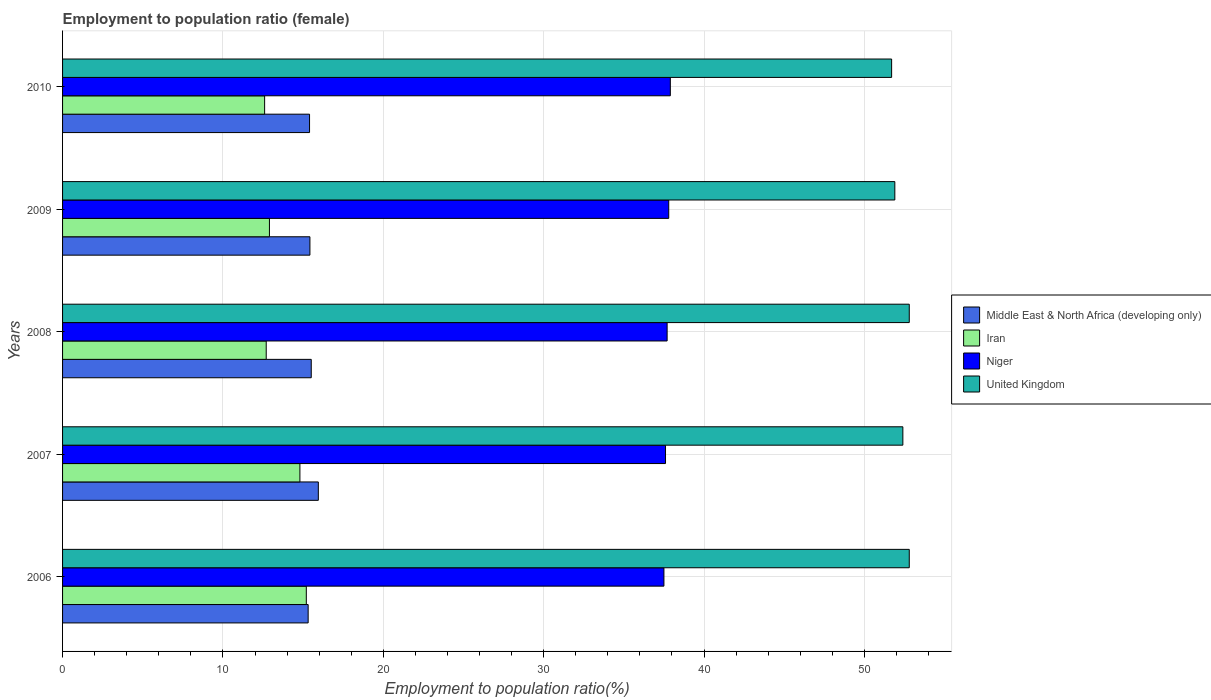How many different coloured bars are there?
Keep it short and to the point. 4. Are the number of bars per tick equal to the number of legend labels?
Provide a short and direct response. Yes. How many bars are there on the 3rd tick from the top?
Your answer should be very brief. 4. What is the label of the 2nd group of bars from the top?
Offer a terse response. 2009. In how many cases, is the number of bars for a given year not equal to the number of legend labels?
Ensure brevity in your answer.  0. What is the employment to population ratio in United Kingdom in 2009?
Make the answer very short. 51.9. Across all years, what is the maximum employment to population ratio in Iran?
Make the answer very short. 15.2. Across all years, what is the minimum employment to population ratio in United Kingdom?
Provide a succinct answer. 51.7. In which year was the employment to population ratio in United Kingdom maximum?
Keep it short and to the point. 2006. What is the total employment to population ratio in Iran in the graph?
Offer a very short reply. 68.2. What is the difference between the employment to population ratio in Niger in 2007 and that in 2009?
Your answer should be compact. -0.2. What is the average employment to population ratio in Iran per year?
Ensure brevity in your answer.  13.64. In the year 2006, what is the difference between the employment to population ratio in United Kingdom and employment to population ratio in Niger?
Provide a short and direct response. 15.3. In how many years, is the employment to population ratio in Iran greater than 18 %?
Keep it short and to the point. 0. What is the ratio of the employment to population ratio in Niger in 2006 to that in 2009?
Ensure brevity in your answer.  0.99. Is the employment to population ratio in Niger in 2006 less than that in 2007?
Provide a succinct answer. Yes. Is the difference between the employment to population ratio in United Kingdom in 2009 and 2010 greater than the difference between the employment to population ratio in Niger in 2009 and 2010?
Keep it short and to the point. Yes. What is the difference between the highest and the second highest employment to population ratio in Iran?
Your answer should be compact. 0.4. What is the difference between the highest and the lowest employment to population ratio in Niger?
Your response must be concise. 0.4. In how many years, is the employment to population ratio in Iran greater than the average employment to population ratio in Iran taken over all years?
Your answer should be compact. 2. Is the sum of the employment to population ratio in Iran in 2008 and 2009 greater than the maximum employment to population ratio in United Kingdom across all years?
Your response must be concise. No. What does the 1st bar from the top in 2007 represents?
Offer a very short reply. United Kingdom. What does the 1st bar from the bottom in 2009 represents?
Make the answer very short. Middle East & North Africa (developing only). Is it the case that in every year, the sum of the employment to population ratio in Middle East & North Africa (developing only) and employment to population ratio in Niger is greater than the employment to population ratio in United Kingdom?
Offer a terse response. Yes. How many bars are there?
Your answer should be compact. 20. Does the graph contain any zero values?
Your answer should be compact. No. Where does the legend appear in the graph?
Your response must be concise. Center right. How are the legend labels stacked?
Give a very brief answer. Vertical. What is the title of the graph?
Provide a succinct answer. Employment to population ratio (female). Does "Panama" appear as one of the legend labels in the graph?
Your response must be concise. No. What is the label or title of the X-axis?
Your answer should be very brief. Employment to population ratio(%). What is the label or title of the Y-axis?
Give a very brief answer. Years. What is the Employment to population ratio(%) of Middle East & North Africa (developing only) in 2006?
Provide a short and direct response. 15.31. What is the Employment to population ratio(%) of Iran in 2006?
Offer a very short reply. 15.2. What is the Employment to population ratio(%) of Niger in 2006?
Offer a terse response. 37.5. What is the Employment to population ratio(%) in United Kingdom in 2006?
Make the answer very short. 52.8. What is the Employment to population ratio(%) of Middle East & North Africa (developing only) in 2007?
Offer a terse response. 15.95. What is the Employment to population ratio(%) of Iran in 2007?
Your answer should be compact. 14.8. What is the Employment to population ratio(%) in Niger in 2007?
Keep it short and to the point. 37.6. What is the Employment to population ratio(%) of United Kingdom in 2007?
Keep it short and to the point. 52.4. What is the Employment to population ratio(%) of Middle East & North Africa (developing only) in 2008?
Your response must be concise. 15.51. What is the Employment to population ratio(%) in Iran in 2008?
Give a very brief answer. 12.7. What is the Employment to population ratio(%) of Niger in 2008?
Your response must be concise. 37.7. What is the Employment to population ratio(%) in United Kingdom in 2008?
Offer a terse response. 52.8. What is the Employment to population ratio(%) in Middle East & North Africa (developing only) in 2009?
Offer a very short reply. 15.42. What is the Employment to population ratio(%) in Iran in 2009?
Your answer should be very brief. 12.9. What is the Employment to population ratio(%) of Niger in 2009?
Give a very brief answer. 37.8. What is the Employment to population ratio(%) in United Kingdom in 2009?
Your answer should be very brief. 51.9. What is the Employment to population ratio(%) of Middle East & North Africa (developing only) in 2010?
Give a very brief answer. 15.4. What is the Employment to population ratio(%) of Iran in 2010?
Your response must be concise. 12.6. What is the Employment to population ratio(%) of Niger in 2010?
Your answer should be compact. 37.9. What is the Employment to population ratio(%) of United Kingdom in 2010?
Offer a very short reply. 51.7. Across all years, what is the maximum Employment to population ratio(%) in Middle East & North Africa (developing only)?
Offer a terse response. 15.95. Across all years, what is the maximum Employment to population ratio(%) of Iran?
Your answer should be very brief. 15.2. Across all years, what is the maximum Employment to population ratio(%) in Niger?
Ensure brevity in your answer.  37.9. Across all years, what is the maximum Employment to population ratio(%) in United Kingdom?
Ensure brevity in your answer.  52.8. Across all years, what is the minimum Employment to population ratio(%) in Middle East & North Africa (developing only)?
Give a very brief answer. 15.31. Across all years, what is the minimum Employment to population ratio(%) of Iran?
Make the answer very short. 12.6. Across all years, what is the minimum Employment to population ratio(%) of Niger?
Offer a terse response. 37.5. Across all years, what is the minimum Employment to population ratio(%) of United Kingdom?
Provide a succinct answer. 51.7. What is the total Employment to population ratio(%) in Middle East & North Africa (developing only) in the graph?
Your response must be concise. 77.6. What is the total Employment to population ratio(%) of Iran in the graph?
Offer a very short reply. 68.2. What is the total Employment to population ratio(%) in Niger in the graph?
Provide a short and direct response. 188.5. What is the total Employment to population ratio(%) in United Kingdom in the graph?
Your response must be concise. 261.6. What is the difference between the Employment to population ratio(%) of Middle East & North Africa (developing only) in 2006 and that in 2007?
Ensure brevity in your answer.  -0.64. What is the difference between the Employment to population ratio(%) in Iran in 2006 and that in 2007?
Provide a succinct answer. 0.4. What is the difference between the Employment to population ratio(%) in Middle East & North Africa (developing only) in 2006 and that in 2008?
Provide a succinct answer. -0.19. What is the difference between the Employment to population ratio(%) in Iran in 2006 and that in 2008?
Give a very brief answer. 2.5. What is the difference between the Employment to population ratio(%) of Middle East & North Africa (developing only) in 2006 and that in 2009?
Your answer should be compact. -0.11. What is the difference between the Employment to population ratio(%) of Middle East & North Africa (developing only) in 2006 and that in 2010?
Your response must be concise. -0.09. What is the difference between the Employment to population ratio(%) in Iran in 2006 and that in 2010?
Your answer should be compact. 2.6. What is the difference between the Employment to population ratio(%) of Niger in 2006 and that in 2010?
Your response must be concise. -0.4. What is the difference between the Employment to population ratio(%) in Middle East & North Africa (developing only) in 2007 and that in 2008?
Provide a succinct answer. 0.44. What is the difference between the Employment to population ratio(%) of Iran in 2007 and that in 2008?
Your answer should be very brief. 2.1. What is the difference between the Employment to population ratio(%) of United Kingdom in 2007 and that in 2008?
Offer a very short reply. -0.4. What is the difference between the Employment to population ratio(%) in Middle East & North Africa (developing only) in 2007 and that in 2009?
Provide a short and direct response. 0.52. What is the difference between the Employment to population ratio(%) in Middle East & North Africa (developing only) in 2007 and that in 2010?
Your answer should be compact. 0.55. What is the difference between the Employment to population ratio(%) in Iran in 2007 and that in 2010?
Provide a short and direct response. 2.2. What is the difference between the Employment to population ratio(%) of Middle East & North Africa (developing only) in 2008 and that in 2009?
Keep it short and to the point. 0.08. What is the difference between the Employment to population ratio(%) of Iran in 2008 and that in 2009?
Make the answer very short. -0.2. What is the difference between the Employment to population ratio(%) of United Kingdom in 2008 and that in 2009?
Your response must be concise. 0.9. What is the difference between the Employment to population ratio(%) of Middle East & North Africa (developing only) in 2008 and that in 2010?
Your answer should be very brief. 0.11. What is the difference between the Employment to population ratio(%) in Iran in 2008 and that in 2010?
Provide a succinct answer. 0.1. What is the difference between the Employment to population ratio(%) in Niger in 2008 and that in 2010?
Your response must be concise. -0.2. What is the difference between the Employment to population ratio(%) of Middle East & North Africa (developing only) in 2009 and that in 2010?
Give a very brief answer. 0.02. What is the difference between the Employment to population ratio(%) in Iran in 2009 and that in 2010?
Ensure brevity in your answer.  0.3. What is the difference between the Employment to population ratio(%) of Niger in 2009 and that in 2010?
Your answer should be very brief. -0.1. What is the difference between the Employment to population ratio(%) in United Kingdom in 2009 and that in 2010?
Your response must be concise. 0.2. What is the difference between the Employment to population ratio(%) of Middle East & North Africa (developing only) in 2006 and the Employment to population ratio(%) of Iran in 2007?
Your response must be concise. 0.51. What is the difference between the Employment to population ratio(%) of Middle East & North Africa (developing only) in 2006 and the Employment to population ratio(%) of Niger in 2007?
Keep it short and to the point. -22.29. What is the difference between the Employment to population ratio(%) of Middle East & North Africa (developing only) in 2006 and the Employment to population ratio(%) of United Kingdom in 2007?
Offer a terse response. -37.09. What is the difference between the Employment to population ratio(%) of Iran in 2006 and the Employment to population ratio(%) of Niger in 2007?
Offer a very short reply. -22.4. What is the difference between the Employment to population ratio(%) of Iran in 2006 and the Employment to population ratio(%) of United Kingdom in 2007?
Provide a succinct answer. -37.2. What is the difference between the Employment to population ratio(%) in Niger in 2006 and the Employment to population ratio(%) in United Kingdom in 2007?
Give a very brief answer. -14.9. What is the difference between the Employment to population ratio(%) in Middle East & North Africa (developing only) in 2006 and the Employment to population ratio(%) in Iran in 2008?
Offer a very short reply. 2.61. What is the difference between the Employment to population ratio(%) of Middle East & North Africa (developing only) in 2006 and the Employment to population ratio(%) of Niger in 2008?
Ensure brevity in your answer.  -22.39. What is the difference between the Employment to population ratio(%) in Middle East & North Africa (developing only) in 2006 and the Employment to population ratio(%) in United Kingdom in 2008?
Offer a terse response. -37.49. What is the difference between the Employment to population ratio(%) of Iran in 2006 and the Employment to population ratio(%) of Niger in 2008?
Make the answer very short. -22.5. What is the difference between the Employment to population ratio(%) of Iran in 2006 and the Employment to population ratio(%) of United Kingdom in 2008?
Your answer should be very brief. -37.6. What is the difference between the Employment to population ratio(%) of Niger in 2006 and the Employment to population ratio(%) of United Kingdom in 2008?
Your answer should be very brief. -15.3. What is the difference between the Employment to population ratio(%) in Middle East & North Africa (developing only) in 2006 and the Employment to population ratio(%) in Iran in 2009?
Give a very brief answer. 2.41. What is the difference between the Employment to population ratio(%) in Middle East & North Africa (developing only) in 2006 and the Employment to population ratio(%) in Niger in 2009?
Your answer should be compact. -22.49. What is the difference between the Employment to population ratio(%) in Middle East & North Africa (developing only) in 2006 and the Employment to population ratio(%) in United Kingdom in 2009?
Offer a very short reply. -36.59. What is the difference between the Employment to population ratio(%) of Iran in 2006 and the Employment to population ratio(%) of Niger in 2009?
Offer a terse response. -22.6. What is the difference between the Employment to population ratio(%) in Iran in 2006 and the Employment to population ratio(%) in United Kingdom in 2009?
Your response must be concise. -36.7. What is the difference between the Employment to population ratio(%) in Niger in 2006 and the Employment to population ratio(%) in United Kingdom in 2009?
Provide a succinct answer. -14.4. What is the difference between the Employment to population ratio(%) in Middle East & North Africa (developing only) in 2006 and the Employment to population ratio(%) in Iran in 2010?
Give a very brief answer. 2.71. What is the difference between the Employment to population ratio(%) of Middle East & North Africa (developing only) in 2006 and the Employment to population ratio(%) of Niger in 2010?
Provide a short and direct response. -22.59. What is the difference between the Employment to population ratio(%) of Middle East & North Africa (developing only) in 2006 and the Employment to population ratio(%) of United Kingdom in 2010?
Ensure brevity in your answer.  -36.39. What is the difference between the Employment to population ratio(%) of Iran in 2006 and the Employment to population ratio(%) of Niger in 2010?
Offer a very short reply. -22.7. What is the difference between the Employment to population ratio(%) in Iran in 2006 and the Employment to population ratio(%) in United Kingdom in 2010?
Make the answer very short. -36.5. What is the difference between the Employment to population ratio(%) of Niger in 2006 and the Employment to population ratio(%) of United Kingdom in 2010?
Ensure brevity in your answer.  -14.2. What is the difference between the Employment to population ratio(%) of Middle East & North Africa (developing only) in 2007 and the Employment to population ratio(%) of Iran in 2008?
Give a very brief answer. 3.25. What is the difference between the Employment to population ratio(%) of Middle East & North Africa (developing only) in 2007 and the Employment to population ratio(%) of Niger in 2008?
Ensure brevity in your answer.  -21.75. What is the difference between the Employment to population ratio(%) of Middle East & North Africa (developing only) in 2007 and the Employment to population ratio(%) of United Kingdom in 2008?
Your response must be concise. -36.85. What is the difference between the Employment to population ratio(%) of Iran in 2007 and the Employment to population ratio(%) of Niger in 2008?
Your answer should be compact. -22.9. What is the difference between the Employment to population ratio(%) of Iran in 2007 and the Employment to population ratio(%) of United Kingdom in 2008?
Provide a short and direct response. -38. What is the difference between the Employment to population ratio(%) in Niger in 2007 and the Employment to population ratio(%) in United Kingdom in 2008?
Offer a very short reply. -15.2. What is the difference between the Employment to population ratio(%) in Middle East & North Africa (developing only) in 2007 and the Employment to population ratio(%) in Iran in 2009?
Your response must be concise. 3.05. What is the difference between the Employment to population ratio(%) of Middle East & North Africa (developing only) in 2007 and the Employment to population ratio(%) of Niger in 2009?
Offer a terse response. -21.85. What is the difference between the Employment to population ratio(%) of Middle East & North Africa (developing only) in 2007 and the Employment to population ratio(%) of United Kingdom in 2009?
Give a very brief answer. -35.95. What is the difference between the Employment to population ratio(%) of Iran in 2007 and the Employment to population ratio(%) of Niger in 2009?
Keep it short and to the point. -23. What is the difference between the Employment to population ratio(%) of Iran in 2007 and the Employment to population ratio(%) of United Kingdom in 2009?
Offer a very short reply. -37.1. What is the difference between the Employment to population ratio(%) in Niger in 2007 and the Employment to population ratio(%) in United Kingdom in 2009?
Offer a terse response. -14.3. What is the difference between the Employment to population ratio(%) of Middle East & North Africa (developing only) in 2007 and the Employment to population ratio(%) of Iran in 2010?
Make the answer very short. 3.35. What is the difference between the Employment to population ratio(%) in Middle East & North Africa (developing only) in 2007 and the Employment to population ratio(%) in Niger in 2010?
Your response must be concise. -21.95. What is the difference between the Employment to population ratio(%) of Middle East & North Africa (developing only) in 2007 and the Employment to population ratio(%) of United Kingdom in 2010?
Make the answer very short. -35.75. What is the difference between the Employment to population ratio(%) of Iran in 2007 and the Employment to population ratio(%) of Niger in 2010?
Your answer should be compact. -23.1. What is the difference between the Employment to population ratio(%) of Iran in 2007 and the Employment to population ratio(%) of United Kingdom in 2010?
Ensure brevity in your answer.  -36.9. What is the difference between the Employment to population ratio(%) of Niger in 2007 and the Employment to population ratio(%) of United Kingdom in 2010?
Your answer should be very brief. -14.1. What is the difference between the Employment to population ratio(%) in Middle East & North Africa (developing only) in 2008 and the Employment to population ratio(%) in Iran in 2009?
Keep it short and to the point. 2.61. What is the difference between the Employment to population ratio(%) of Middle East & North Africa (developing only) in 2008 and the Employment to population ratio(%) of Niger in 2009?
Provide a short and direct response. -22.29. What is the difference between the Employment to population ratio(%) of Middle East & North Africa (developing only) in 2008 and the Employment to population ratio(%) of United Kingdom in 2009?
Give a very brief answer. -36.39. What is the difference between the Employment to population ratio(%) in Iran in 2008 and the Employment to population ratio(%) in Niger in 2009?
Offer a terse response. -25.1. What is the difference between the Employment to population ratio(%) in Iran in 2008 and the Employment to population ratio(%) in United Kingdom in 2009?
Your response must be concise. -39.2. What is the difference between the Employment to population ratio(%) of Niger in 2008 and the Employment to population ratio(%) of United Kingdom in 2009?
Offer a terse response. -14.2. What is the difference between the Employment to population ratio(%) of Middle East & North Africa (developing only) in 2008 and the Employment to population ratio(%) of Iran in 2010?
Give a very brief answer. 2.91. What is the difference between the Employment to population ratio(%) in Middle East & North Africa (developing only) in 2008 and the Employment to population ratio(%) in Niger in 2010?
Keep it short and to the point. -22.39. What is the difference between the Employment to population ratio(%) in Middle East & North Africa (developing only) in 2008 and the Employment to population ratio(%) in United Kingdom in 2010?
Your answer should be compact. -36.19. What is the difference between the Employment to population ratio(%) of Iran in 2008 and the Employment to population ratio(%) of Niger in 2010?
Keep it short and to the point. -25.2. What is the difference between the Employment to population ratio(%) in Iran in 2008 and the Employment to population ratio(%) in United Kingdom in 2010?
Make the answer very short. -39. What is the difference between the Employment to population ratio(%) in Middle East & North Africa (developing only) in 2009 and the Employment to population ratio(%) in Iran in 2010?
Your answer should be very brief. 2.82. What is the difference between the Employment to population ratio(%) in Middle East & North Africa (developing only) in 2009 and the Employment to population ratio(%) in Niger in 2010?
Give a very brief answer. -22.48. What is the difference between the Employment to population ratio(%) in Middle East & North Africa (developing only) in 2009 and the Employment to population ratio(%) in United Kingdom in 2010?
Give a very brief answer. -36.28. What is the difference between the Employment to population ratio(%) of Iran in 2009 and the Employment to population ratio(%) of United Kingdom in 2010?
Provide a short and direct response. -38.8. What is the difference between the Employment to population ratio(%) in Niger in 2009 and the Employment to population ratio(%) in United Kingdom in 2010?
Your answer should be compact. -13.9. What is the average Employment to population ratio(%) in Middle East & North Africa (developing only) per year?
Offer a terse response. 15.52. What is the average Employment to population ratio(%) of Iran per year?
Give a very brief answer. 13.64. What is the average Employment to population ratio(%) of Niger per year?
Provide a short and direct response. 37.7. What is the average Employment to population ratio(%) in United Kingdom per year?
Offer a terse response. 52.32. In the year 2006, what is the difference between the Employment to population ratio(%) in Middle East & North Africa (developing only) and Employment to population ratio(%) in Iran?
Your answer should be compact. 0.11. In the year 2006, what is the difference between the Employment to population ratio(%) in Middle East & North Africa (developing only) and Employment to population ratio(%) in Niger?
Your answer should be very brief. -22.19. In the year 2006, what is the difference between the Employment to population ratio(%) in Middle East & North Africa (developing only) and Employment to population ratio(%) in United Kingdom?
Keep it short and to the point. -37.49. In the year 2006, what is the difference between the Employment to population ratio(%) in Iran and Employment to population ratio(%) in Niger?
Make the answer very short. -22.3. In the year 2006, what is the difference between the Employment to population ratio(%) of Iran and Employment to population ratio(%) of United Kingdom?
Offer a very short reply. -37.6. In the year 2006, what is the difference between the Employment to population ratio(%) in Niger and Employment to population ratio(%) in United Kingdom?
Make the answer very short. -15.3. In the year 2007, what is the difference between the Employment to population ratio(%) of Middle East & North Africa (developing only) and Employment to population ratio(%) of Iran?
Give a very brief answer. 1.15. In the year 2007, what is the difference between the Employment to population ratio(%) of Middle East & North Africa (developing only) and Employment to population ratio(%) of Niger?
Provide a succinct answer. -21.65. In the year 2007, what is the difference between the Employment to population ratio(%) of Middle East & North Africa (developing only) and Employment to population ratio(%) of United Kingdom?
Your answer should be compact. -36.45. In the year 2007, what is the difference between the Employment to population ratio(%) in Iran and Employment to population ratio(%) in Niger?
Ensure brevity in your answer.  -22.8. In the year 2007, what is the difference between the Employment to population ratio(%) in Iran and Employment to population ratio(%) in United Kingdom?
Provide a short and direct response. -37.6. In the year 2007, what is the difference between the Employment to population ratio(%) in Niger and Employment to population ratio(%) in United Kingdom?
Give a very brief answer. -14.8. In the year 2008, what is the difference between the Employment to population ratio(%) of Middle East & North Africa (developing only) and Employment to population ratio(%) of Iran?
Your response must be concise. 2.81. In the year 2008, what is the difference between the Employment to population ratio(%) of Middle East & North Africa (developing only) and Employment to population ratio(%) of Niger?
Keep it short and to the point. -22.19. In the year 2008, what is the difference between the Employment to population ratio(%) in Middle East & North Africa (developing only) and Employment to population ratio(%) in United Kingdom?
Your response must be concise. -37.29. In the year 2008, what is the difference between the Employment to population ratio(%) in Iran and Employment to population ratio(%) in Niger?
Ensure brevity in your answer.  -25. In the year 2008, what is the difference between the Employment to population ratio(%) in Iran and Employment to population ratio(%) in United Kingdom?
Ensure brevity in your answer.  -40.1. In the year 2008, what is the difference between the Employment to population ratio(%) of Niger and Employment to population ratio(%) of United Kingdom?
Offer a terse response. -15.1. In the year 2009, what is the difference between the Employment to population ratio(%) in Middle East & North Africa (developing only) and Employment to population ratio(%) in Iran?
Keep it short and to the point. 2.52. In the year 2009, what is the difference between the Employment to population ratio(%) in Middle East & North Africa (developing only) and Employment to population ratio(%) in Niger?
Offer a very short reply. -22.38. In the year 2009, what is the difference between the Employment to population ratio(%) in Middle East & North Africa (developing only) and Employment to population ratio(%) in United Kingdom?
Provide a succinct answer. -36.48. In the year 2009, what is the difference between the Employment to population ratio(%) of Iran and Employment to population ratio(%) of Niger?
Provide a succinct answer. -24.9. In the year 2009, what is the difference between the Employment to population ratio(%) of Iran and Employment to population ratio(%) of United Kingdom?
Your answer should be compact. -39. In the year 2009, what is the difference between the Employment to population ratio(%) of Niger and Employment to population ratio(%) of United Kingdom?
Your answer should be compact. -14.1. In the year 2010, what is the difference between the Employment to population ratio(%) in Middle East & North Africa (developing only) and Employment to population ratio(%) in Iran?
Provide a short and direct response. 2.8. In the year 2010, what is the difference between the Employment to population ratio(%) of Middle East & North Africa (developing only) and Employment to population ratio(%) of Niger?
Make the answer very short. -22.5. In the year 2010, what is the difference between the Employment to population ratio(%) in Middle East & North Africa (developing only) and Employment to population ratio(%) in United Kingdom?
Your answer should be compact. -36.3. In the year 2010, what is the difference between the Employment to population ratio(%) of Iran and Employment to population ratio(%) of Niger?
Ensure brevity in your answer.  -25.3. In the year 2010, what is the difference between the Employment to population ratio(%) in Iran and Employment to population ratio(%) in United Kingdom?
Your answer should be compact. -39.1. What is the ratio of the Employment to population ratio(%) in Middle East & North Africa (developing only) in 2006 to that in 2007?
Your answer should be very brief. 0.96. What is the ratio of the Employment to population ratio(%) of Niger in 2006 to that in 2007?
Provide a succinct answer. 1. What is the ratio of the Employment to population ratio(%) in United Kingdom in 2006 to that in 2007?
Keep it short and to the point. 1.01. What is the ratio of the Employment to population ratio(%) in Middle East & North Africa (developing only) in 2006 to that in 2008?
Offer a terse response. 0.99. What is the ratio of the Employment to population ratio(%) in Iran in 2006 to that in 2008?
Offer a very short reply. 1.2. What is the ratio of the Employment to population ratio(%) of Niger in 2006 to that in 2008?
Your response must be concise. 0.99. What is the ratio of the Employment to population ratio(%) in United Kingdom in 2006 to that in 2008?
Make the answer very short. 1. What is the ratio of the Employment to population ratio(%) in Middle East & North Africa (developing only) in 2006 to that in 2009?
Your response must be concise. 0.99. What is the ratio of the Employment to population ratio(%) in Iran in 2006 to that in 2009?
Offer a very short reply. 1.18. What is the ratio of the Employment to population ratio(%) in Niger in 2006 to that in 2009?
Make the answer very short. 0.99. What is the ratio of the Employment to population ratio(%) in United Kingdom in 2006 to that in 2009?
Provide a succinct answer. 1.02. What is the ratio of the Employment to population ratio(%) of Middle East & North Africa (developing only) in 2006 to that in 2010?
Give a very brief answer. 0.99. What is the ratio of the Employment to population ratio(%) in Iran in 2006 to that in 2010?
Give a very brief answer. 1.21. What is the ratio of the Employment to population ratio(%) in United Kingdom in 2006 to that in 2010?
Keep it short and to the point. 1.02. What is the ratio of the Employment to population ratio(%) of Middle East & North Africa (developing only) in 2007 to that in 2008?
Keep it short and to the point. 1.03. What is the ratio of the Employment to population ratio(%) of Iran in 2007 to that in 2008?
Offer a very short reply. 1.17. What is the ratio of the Employment to population ratio(%) of United Kingdom in 2007 to that in 2008?
Provide a short and direct response. 0.99. What is the ratio of the Employment to population ratio(%) of Middle East & North Africa (developing only) in 2007 to that in 2009?
Keep it short and to the point. 1.03. What is the ratio of the Employment to population ratio(%) of Iran in 2007 to that in 2009?
Provide a short and direct response. 1.15. What is the ratio of the Employment to population ratio(%) of United Kingdom in 2007 to that in 2009?
Offer a very short reply. 1.01. What is the ratio of the Employment to population ratio(%) of Middle East & North Africa (developing only) in 2007 to that in 2010?
Give a very brief answer. 1.04. What is the ratio of the Employment to population ratio(%) in Iran in 2007 to that in 2010?
Keep it short and to the point. 1.17. What is the ratio of the Employment to population ratio(%) in United Kingdom in 2007 to that in 2010?
Keep it short and to the point. 1.01. What is the ratio of the Employment to population ratio(%) of Middle East & North Africa (developing only) in 2008 to that in 2009?
Provide a succinct answer. 1.01. What is the ratio of the Employment to population ratio(%) of Iran in 2008 to that in 2009?
Ensure brevity in your answer.  0.98. What is the ratio of the Employment to population ratio(%) of Niger in 2008 to that in 2009?
Provide a succinct answer. 1. What is the ratio of the Employment to population ratio(%) of United Kingdom in 2008 to that in 2009?
Offer a very short reply. 1.02. What is the ratio of the Employment to population ratio(%) of Middle East & North Africa (developing only) in 2008 to that in 2010?
Provide a succinct answer. 1.01. What is the ratio of the Employment to population ratio(%) of Iran in 2008 to that in 2010?
Provide a succinct answer. 1.01. What is the ratio of the Employment to population ratio(%) in United Kingdom in 2008 to that in 2010?
Offer a very short reply. 1.02. What is the ratio of the Employment to population ratio(%) of Middle East & North Africa (developing only) in 2009 to that in 2010?
Keep it short and to the point. 1. What is the ratio of the Employment to population ratio(%) in Iran in 2009 to that in 2010?
Offer a very short reply. 1.02. What is the ratio of the Employment to population ratio(%) of United Kingdom in 2009 to that in 2010?
Your answer should be very brief. 1. What is the difference between the highest and the second highest Employment to population ratio(%) of Middle East & North Africa (developing only)?
Offer a terse response. 0.44. What is the difference between the highest and the second highest Employment to population ratio(%) of Iran?
Make the answer very short. 0.4. What is the difference between the highest and the second highest Employment to population ratio(%) in Niger?
Offer a very short reply. 0.1. What is the difference between the highest and the second highest Employment to population ratio(%) in United Kingdom?
Offer a very short reply. 0. What is the difference between the highest and the lowest Employment to population ratio(%) of Middle East & North Africa (developing only)?
Provide a succinct answer. 0.64. What is the difference between the highest and the lowest Employment to population ratio(%) of Iran?
Ensure brevity in your answer.  2.6. What is the difference between the highest and the lowest Employment to population ratio(%) in Niger?
Offer a very short reply. 0.4. What is the difference between the highest and the lowest Employment to population ratio(%) in United Kingdom?
Offer a very short reply. 1.1. 